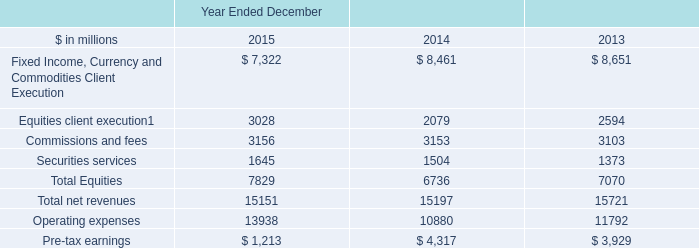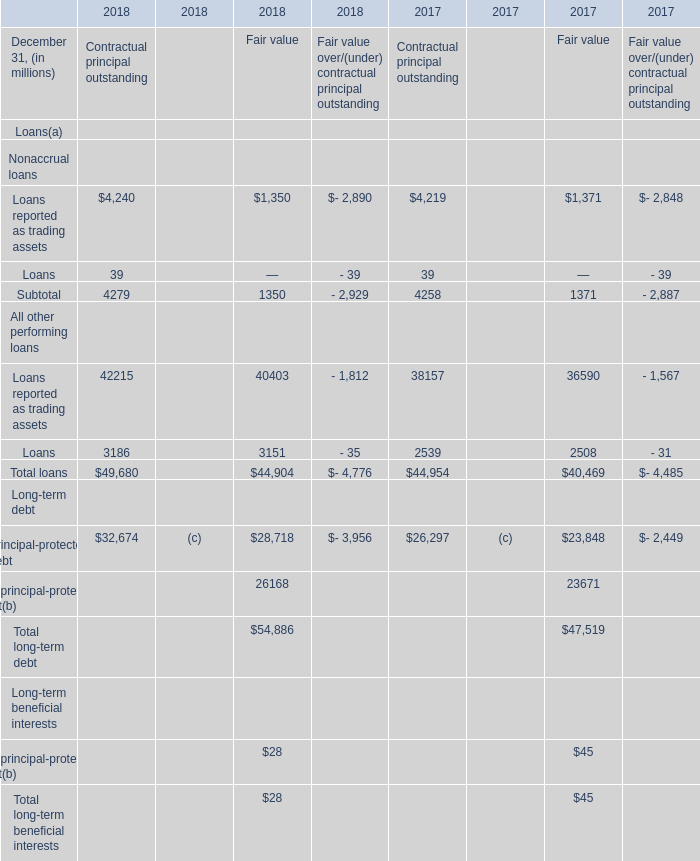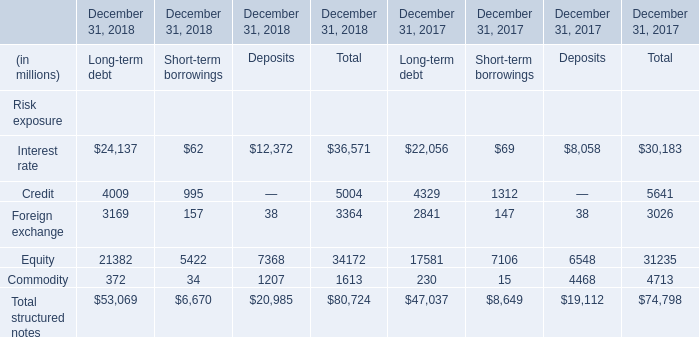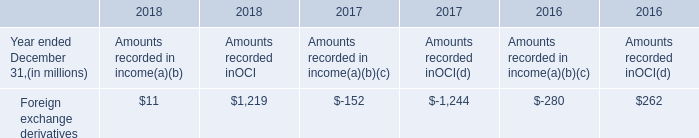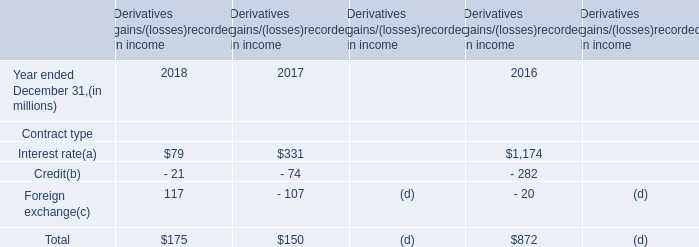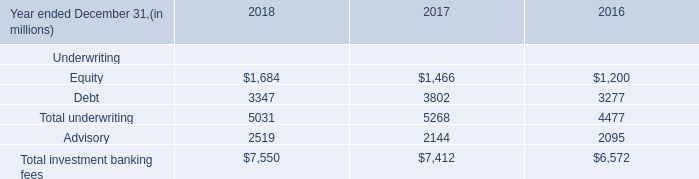Does Principal-protected debt for Contractual principal outstanding keeps increasing each year between 2018 and 2017? 
Answer: Yes. 